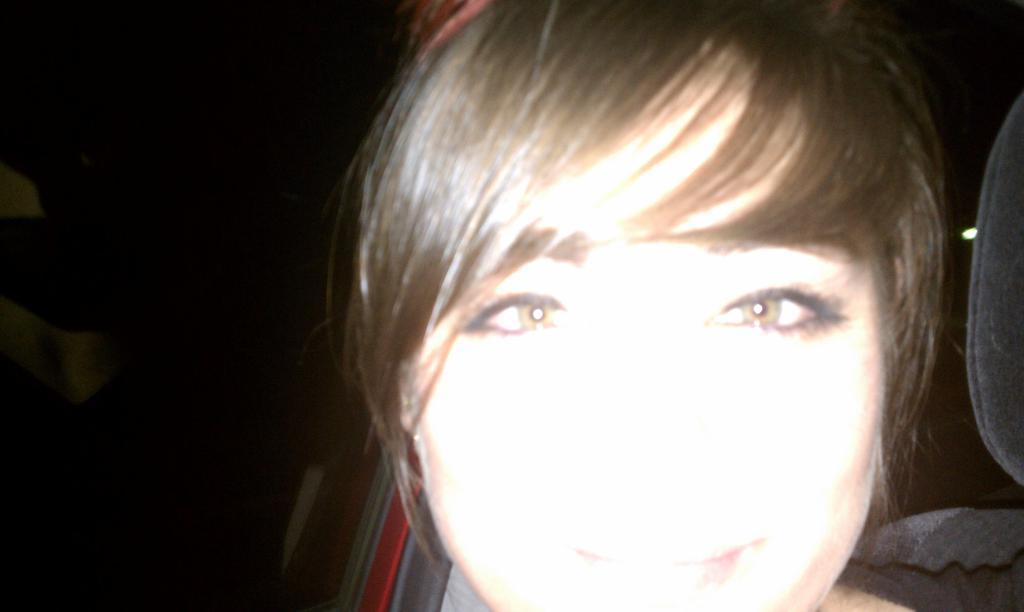Please provide a concise description of this image. In this image we can see a woman. There is a dark background. 